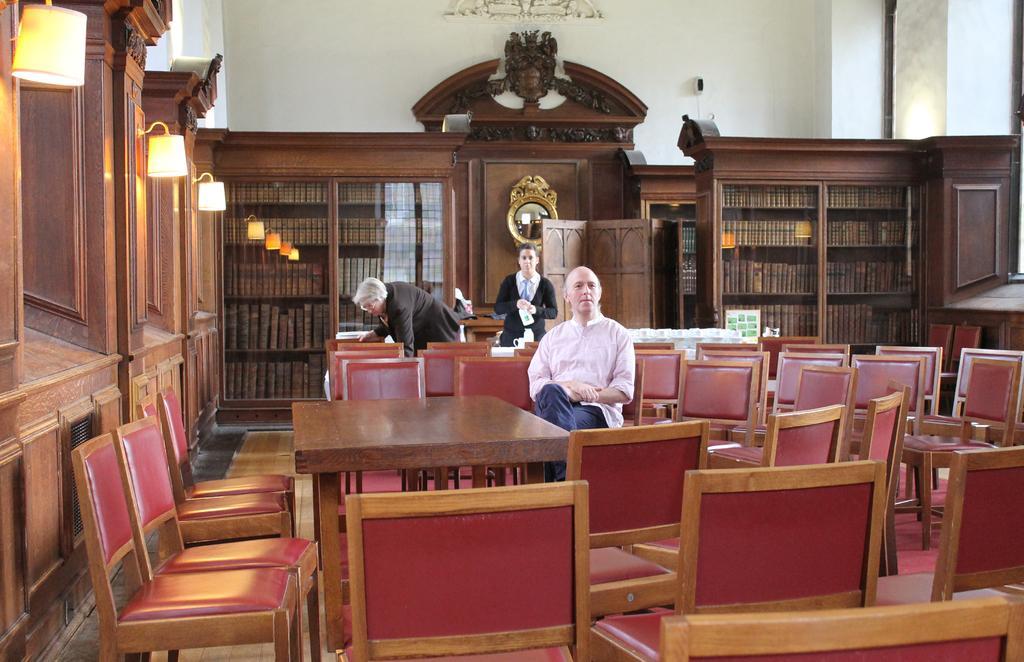Please provide a concise description of this image. In this picture there is a man sitting on the chair. There is a woman standing and there is also another woman standing. There is a light. There is a bookshelf in which books are kept. 